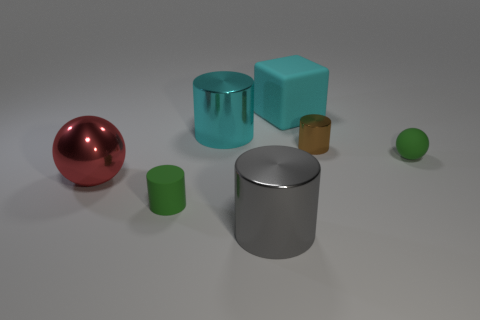Subtract all tiny brown cylinders. How many cylinders are left? 3 Subtract all gray cylinders. How many cylinders are left? 3 Add 2 large gray shiny cylinders. How many objects exist? 9 Subtract all blocks. How many objects are left? 6 Subtract 3 cylinders. How many cylinders are left? 1 Add 2 small green cylinders. How many small green cylinders exist? 3 Subtract 0 yellow cylinders. How many objects are left? 7 Subtract all yellow spheres. Subtract all red cylinders. How many spheres are left? 2 Subtract all small brown metal cylinders. Subtract all brown cylinders. How many objects are left? 5 Add 2 tiny brown cylinders. How many tiny brown cylinders are left? 3 